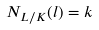<formula> <loc_0><loc_0><loc_500><loc_500>N _ { L / K } ( l ) = k</formula> 